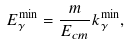<formula> <loc_0><loc_0><loc_500><loc_500>E _ { \gamma } ^ { \min } = \frac { m } { E _ { c m } } k _ { \gamma } ^ { \min } ,</formula> 